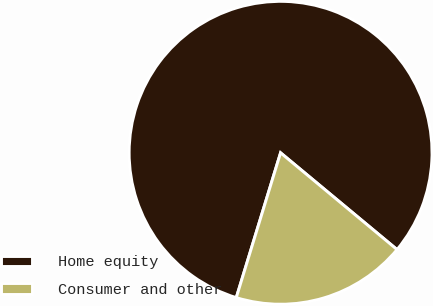Convert chart. <chart><loc_0><loc_0><loc_500><loc_500><pie_chart><fcel>Home equity<fcel>Consumer and other<nl><fcel>81.31%<fcel>18.69%<nl></chart> 